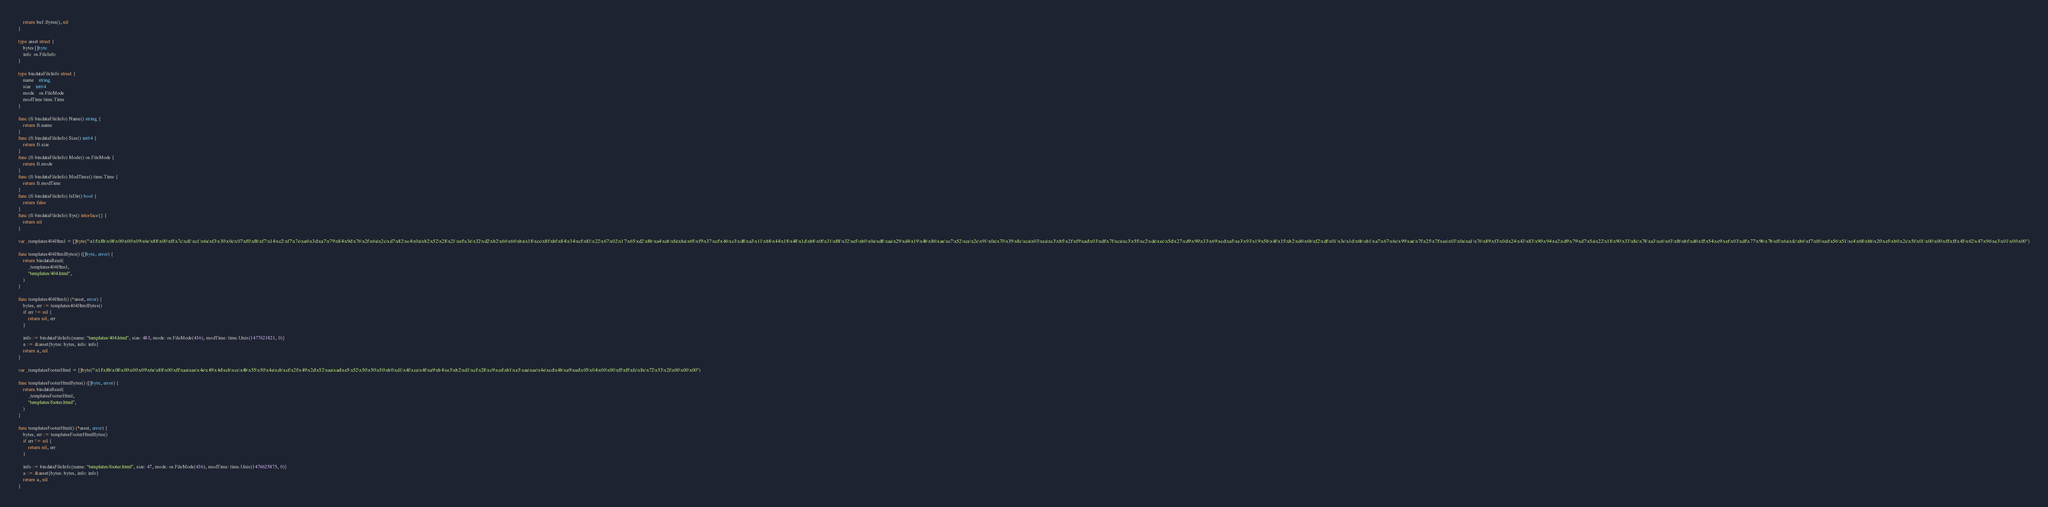Convert code to text. <code><loc_0><loc_0><loc_500><loc_500><_Go_>
	return buf.Bytes(), nil
}

type asset struct {
	bytes []byte
	info  os.FileInfo
}

type bindataFileInfo struct {
	name    string
	size    int64
	mode    os.FileMode
	modTime time.Time
}

func (fi bindataFileInfo) Name() string {
	return fi.name
}
func (fi bindataFileInfo) Size() int64 {
	return fi.size
}
func (fi bindataFileInfo) Mode() os.FileMode {
	return fi.mode
}
func (fi bindataFileInfo) ModTime() time.Time {
	return fi.modTime
}
func (fi bindataFileInfo) IsDir() bool {
	return false
}
func (fi bindataFileInfo) Sys() interface{} {
	return nil
}

var _templates404Html = []byte("\x1f\x8b\x08\x00\x00\x09\x6e\x88\x00\xff\x7c\xd1\xc1\x6a\xf3\x30\x0c\x07\xf0\xfb\xf7\x14\xc2\xf7\x7e\xa6\x3d\xa7\x79\x84\x9d\x76\x2f\x6a\x2c\xd7\x82\xc4\x0a\xb2\x52\x28\x21\xef\x3e\x32\xd2\xb2\x66\x66\xba\x18\xcc\x8f\xbf\x84\x34\xcf\x81\x22\x67\x02\x17\x65\xd2\x8b\xa4\xcb\xfa\xba\x65\xf9\x37\xcf\x46\xc3\xd8\xa3\x11\xb8\x44\x18\x48\x1d\xb8\x0f\x31\x88\x32\xe5\xb0\x0a\xd8\xaa\x29\xd4\x19\x4b\x86\xae\xc7\x52\xce\x2e\x91\x0a\x70\x39\x8c\xca\x03\xea\xc3\xb5\x2f\xf9\xad\x03\xdf\x7f\xca\xc3\x55\xc2\xde\xec\x5d\x27\xd9\x90\x33\x69\xcd\xa5\xe3\x93\x19\x5b\x4f\x15\xb2\xd6\x6b\xf2\xdf\x01\x3e\x1d\x6b\xb1\xa7\x67\x6c\x99\xae\x7f\x25\x7f\xea\x03\x0a\xa1\x76\x89\xf3\x0d\x24\x43\x83\x90\x94\xe2\xd9\x79\xd7\x5a\x22\x18\x90\x33\x8c\x78\xa3\xc6\x63\xfb\xbf\xd6\xff\x54\xe9\xef\x03\xdf\x77\x9b\x7b\xff\x6a\xfc\xb6\xf7\xf6\xed\x56\x51\xc4\x68\xbb\x20\xe5\xb0\x2c\x5f\x01\x00\x00\xff\xff\x45\x62\x47\x96\xe3\x01\x00\x00")

func templates404HtmlBytes() ([]byte, error) {
	return bindataRead(
		_templates404Html,
		"templates/404.html",
	)
}

func templates404Html() (*asset, error) {
	bytes, err := templates404HtmlBytes()
	if err != nil {
		return nil, err
	}

	info := bindataFileInfo{name: "templates/404.html", size: 483, mode: os.FileMode(436), modTime: time.Unix(1477621821, 0)}
	a := &asset{bytes: bytes, info: info}
	return a, nil
}

var _templatesFooterHtml = []byte("\x1f\x8b\x08\x00\x00\x09\x6e\x88\x00\xff\xaa\xae\x4e\x49\x4d\xcb\xcc\x4b\x55\x50\x4a\xcb\xcf\x2f\x49\x2d\x52\xaa\xad\xe5\x52\x50\x50\x50\xb0\xd1\x4f\xca\x4f\xa9\xb4\xe3\xb2\xd1\xcf\x28\xc9\xcd\xb1\xe3\xaa\xae\x4e\xcd\x4b\xa9\xad\x05\x04\x00\x00\xff\xff\xfc\x8e\x72\x53\x2f\x00\x00\x00")

func templatesFooterHtmlBytes() ([]byte, error) {
	return bindataRead(
		_templatesFooterHtml,
		"templates/footer.html",
	)
}

func templatesFooterHtml() (*asset, error) {
	bytes, err := templatesFooterHtmlBytes()
	if err != nil {
		return nil, err
	}

	info := bindataFileInfo{name: "templates/footer.html", size: 47, mode: os.FileMode(436), modTime: time.Unix(1476625875, 0)}
	a := &asset{bytes: bytes, info: info}
	return a, nil
}
</code> 